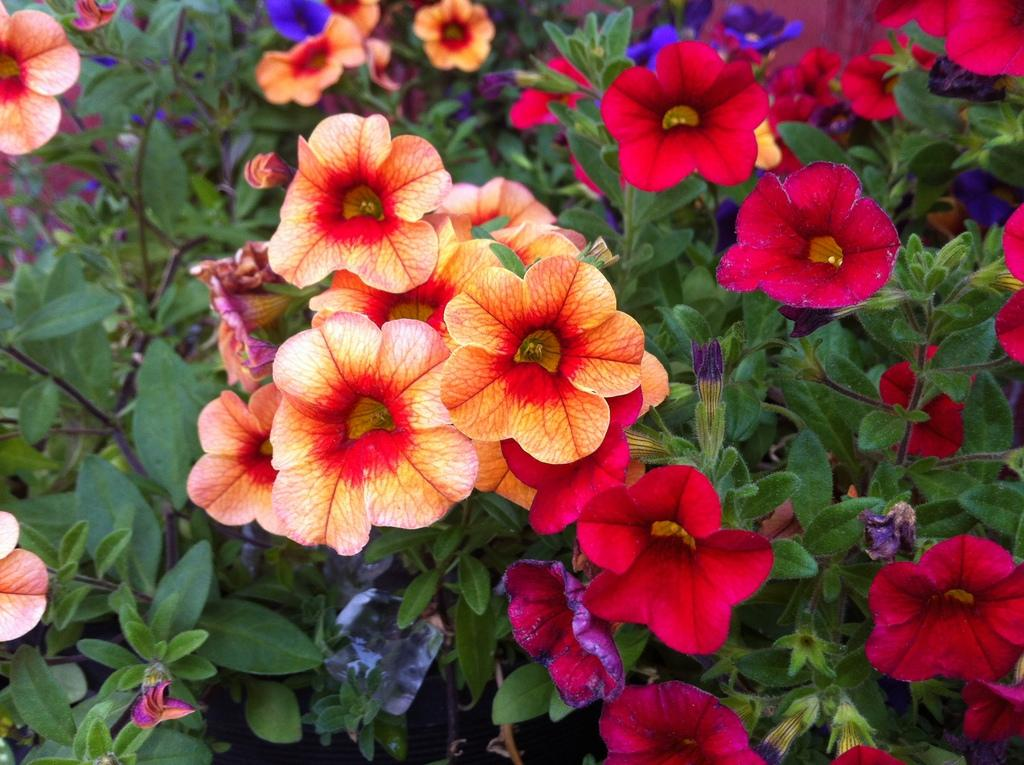What type of living organisms can be seen in the image? There are flowers in the image. How are the flowers connected to the plants? The flowers are attached to the stems of plants. What colors can be observed in the flowers? The flowers have red, purple, and orange colors. What other parts of the plants are visible in the image? There are leaves in the image. Can you describe the nest that is visible in the image? There is no nest present in the image; it features flowers and leaves. What type of rock can be seen supporting the flowers in the image? There is no rock present in the image; the flowers are attached to the stems of plants. 